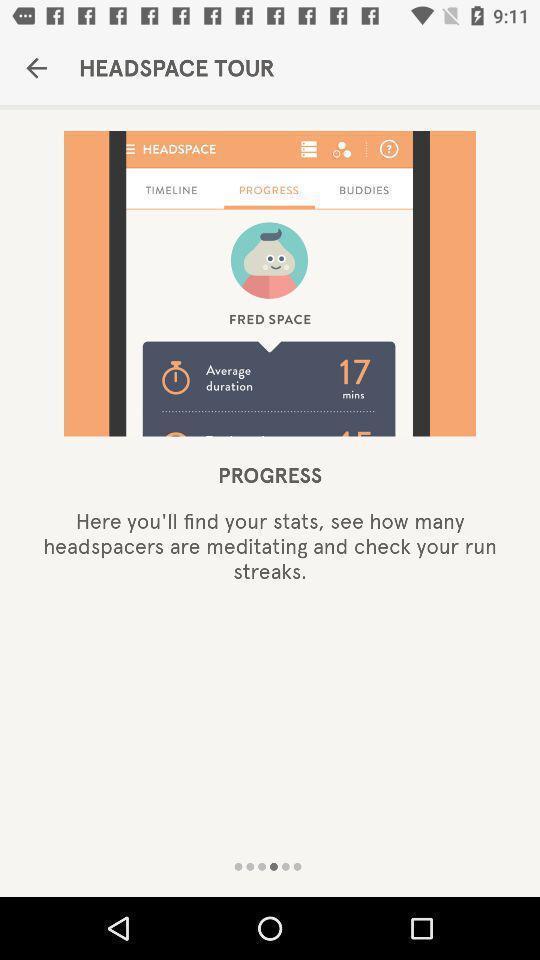Summarize the information in this screenshot. Welcome page displayed. 